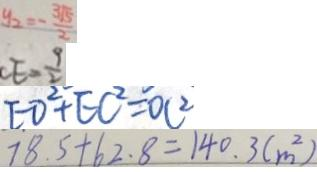<formula> <loc_0><loc_0><loc_500><loc_500>y _ { 2 } = - \frac { 3 \sqrt { 5 } } { 2 } 
 C E = \frac { 9 } { 2 } 
 E D ^ { 2 } + E C ^ { 2 } = O C ^ { 2 } 
 7 8 . 5 + 6 2 . 8 = 1 4 0 . 3 ( m ^ { 2 } )</formula> 